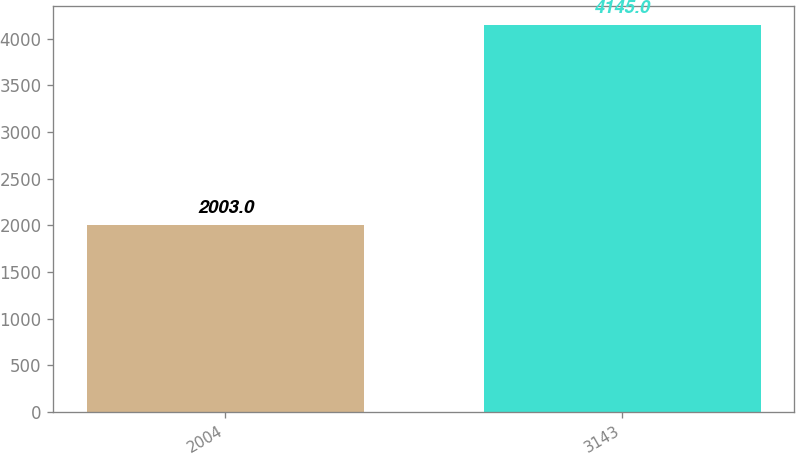<chart> <loc_0><loc_0><loc_500><loc_500><bar_chart><fcel>2004<fcel>3143<nl><fcel>2003<fcel>4145<nl></chart> 